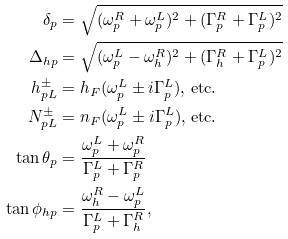<formula> <loc_0><loc_0><loc_500><loc_500>\delta _ { p } & = \sqrt { ( \omega _ { p } ^ { R } + \omega _ { p } ^ { L } ) ^ { 2 } + ( \Gamma _ { p } ^ { R } + \Gamma _ { p } ^ { L } ) ^ { 2 } } \\ \Delta _ { h p } & = \sqrt { ( \omega _ { p } ^ { L } - \omega _ { h } ^ { R } ) ^ { 2 } + ( \Gamma _ { h } ^ { R } + \Gamma _ { p } ^ { L } ) ^ { 2 } } \\ h _ { p L } ^ { \pm } & = h _ { F } ( \omega _ { p } ^ { L } \pm i \Gamma _ { p } ^ { L } ) \text {, etc.} \\ N _ { p L } ^ { \pm } & = n _ { F } ( \omega _ { p } ^ { L } \pm i \Gamma _ { p } ^ { L } ) \text {, etc.} \\ \tan \theta _ { p } & = \frac { \omega _ { p } ^ { L } + \omega _ { p } ^ { R } } { \Gamma _ { p } ^ { L } + \Gamma _ { p } ^ { R } } \\ \tan \phi _ { h p } & = \frac { \omega _ { h } ^ { R } - \omega _ { p } ^ { L } } { \Gamma _ { p } ^ { L } + \Gamma _ { h } ^ { R } } ,</formula> 